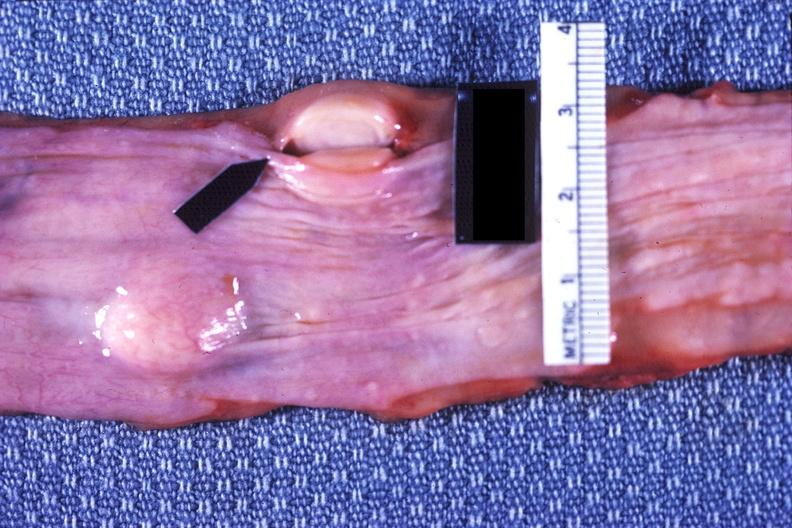where does this belong to?
Answer the question using a single word or phrase. Gastrointestinal system 